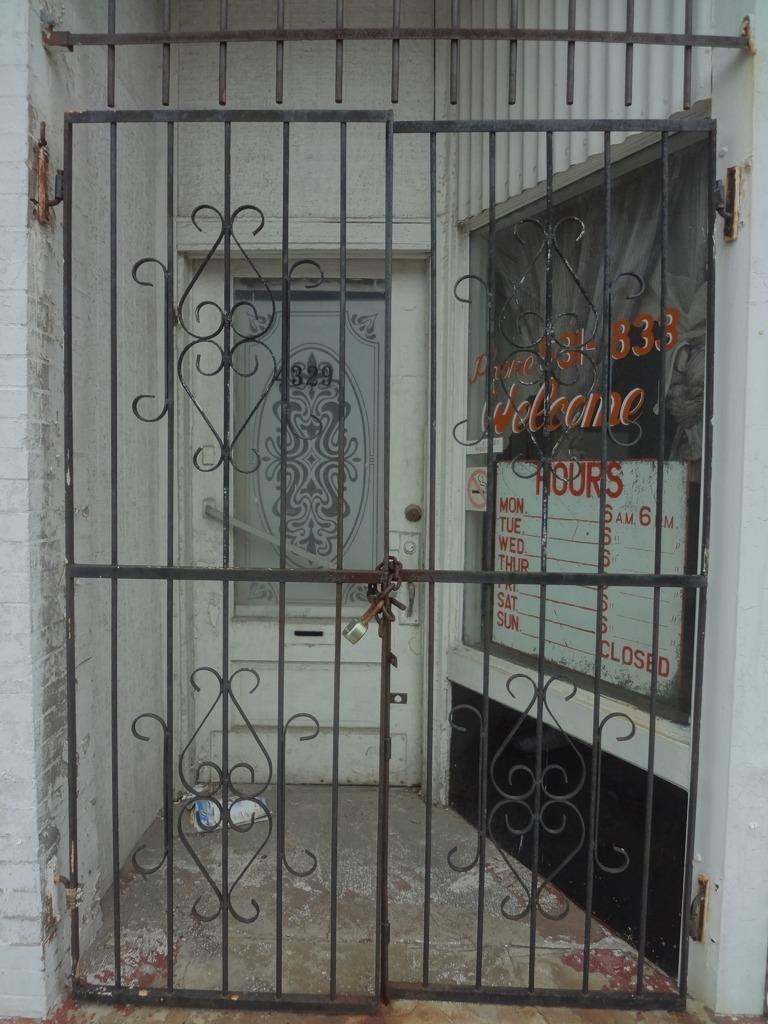What is the main subject of the image? The image depicts an entrance. What is the status of the gate at the entrance? The gate at the entrance is locked. What type of chairs can be seen inside the entrance in the image? There are no chairs visible inside the entrance in the image. 